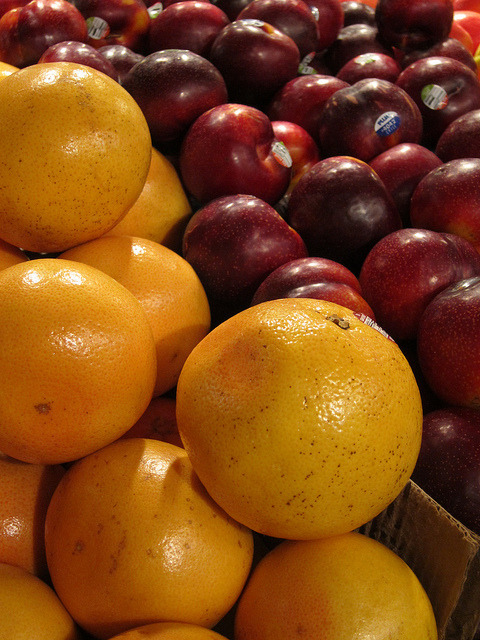Which of these fruits has the higher vitamin C content? Oranges are known for their high vitamin C content, which is considerably higher than that of plums. How do you recommend serving these fruits together? A refreshing fruit salad could be made by combining slices of oranges and plums, perhaps with a drizzle of honey and a sprinkle of fresh mint for added flavor. 